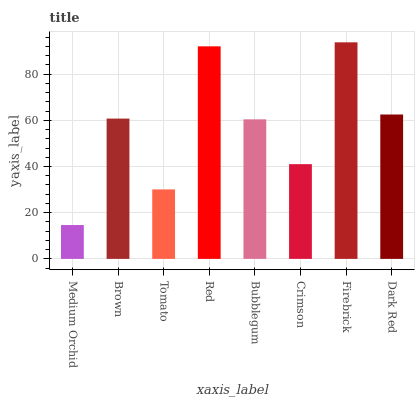Is Medium Orchid the minimum?
Answer yes or no. Yes. Is Firebrick the maximum?
Answer yes or no. Yes. Is Brown the minimum?
Answer yes or no. No. Is Brown the maximum?
Answer yes or no. No. Is Brown greater than Medium Orchid?
Answer yes or no. Yes. Is Medium Orchid less than Brown?
Answer yes or no. Yes. Is Medium Orchid greater than Brown?
Answer yes or no. No. Is Brown less than Medium Orchid?
Answer yes or no. No. Is Brown the high median?
Answer yes or no. Yes. Is Bubblegum the low median?
Answer yes or no. Yes. Is Tomato the high median?
Answer yes or no. No. Is Dark Red the low median?
Answer yes or no. No. 